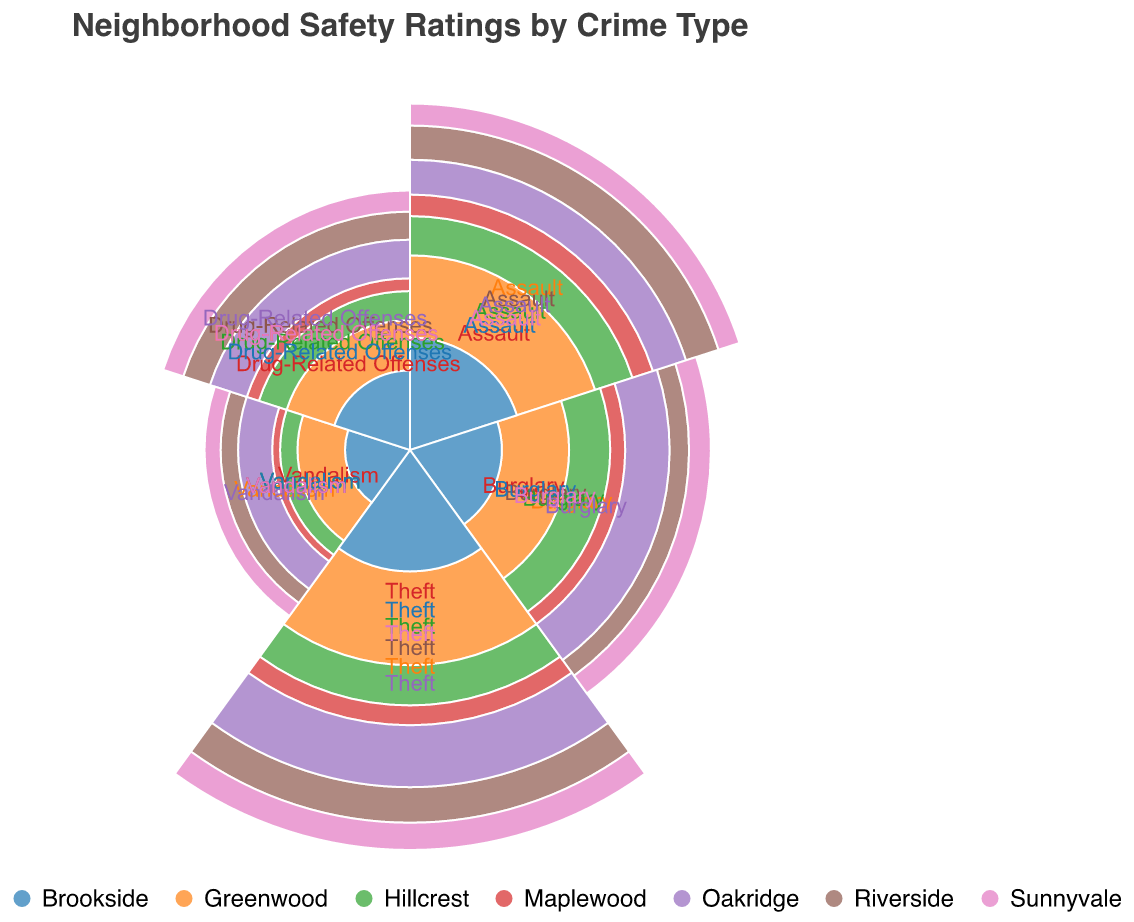What is the title of the figure? The title is typically located at the top of the figure. It is written in a larger and prominent font compared to other text.
Answer: Neighborhood Safety Ratings by Crime Type Which neighborhood has the highest number of 'Theft' crimes? By examining the segment in the polar chart associated with 'Theft' for each neighborhood, the one with the largest radius corresponds to the highest value. Here, Oakridge has the largest segment for 'Theft'.
Answer: Oakridge Which crime type has the lowest value in Maplewood? By looking at the segments for all crime types within Maplewood, the segment with the smallest radius represents the lowest crime value. Here, 'Vandalism' shows the smallest segment for Maplewood.
Answer: Vandalism How does the number of 'Drug-Related Offenses' in Riverside compare to Greenwood? Look at the segments for 'Drug-Related Offenses' for both Riverside and Greenwood. Compare the radii of these segments — the one with a larger radius represents a higher value. Riverside has a value of 6 and Greenwood has a value of 5. Thus, Riverside has more 'Drug-Related Offenses'.
Answer: Riverside has more What is the median value of 'Assault' across all neighborhoods? List the 'Assault' values for all neighborhoods: [12, 10, 8, 5, 9, 6, 7]. Sorting these in ascending order: [5, 6, 7, 8, 9, 10, 12]. The median value is the middle one in this sorted list, which is 8.
Answer: 8 Which neighborhood has the most balanced distribution of crime values? To determine the most balanced distribution, inspect the variance in segment sizes for each neighborhood. Maplewood shows relatively even segment sizes across all crime types compared to others, indicating a more balanced distribution.
Answer: Maplewood How many more 'Burglary' crimes are there in Oakridge compared to Brookside? Identify the 'Burglary' values for Oakridge (10) and Brookside (4). Subtract the smaller value from the larger value: 10 - 4 = 6.
Answer: 6 Which neighborhood has the least 'Vandalism' incidents, and what is the value? Observe the 'Vandalism' segments for all neighborhoods. The smallest segment corresponds to the lowest value. Here, Maplewood has the least incidents with a value of 1.
Answer: Maplewood, 1 What is the sum of 'Assault' incidents in Greenwood and Riverside? Add the 'Assault' values for both Greenwood (12) and Riverside (10). The sum is 12 + 10 = 22.
Answer: 22 